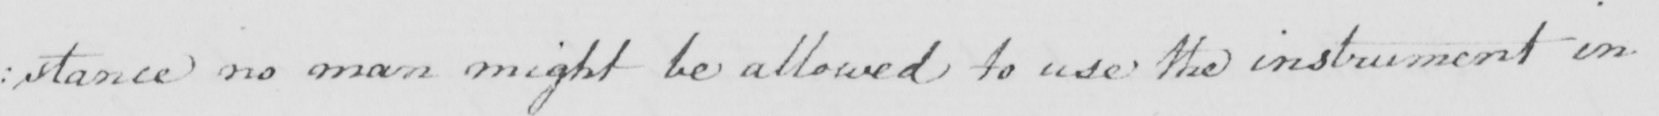What does this handwritten line say? : stance no man might be allowed to use the instument in 